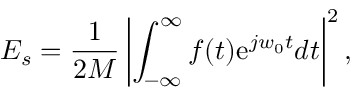Convert formula to latex. <formula><loc_0><loc_0><loc_500><loc_500>E _ { s } = \frac { 1 } { 2 M } \left | \int _ { - \infty } ^ { \infty } f ( t ) e ^ { j w _ { 0 } t } d t \right | ^ { 2 } ,</formula> 